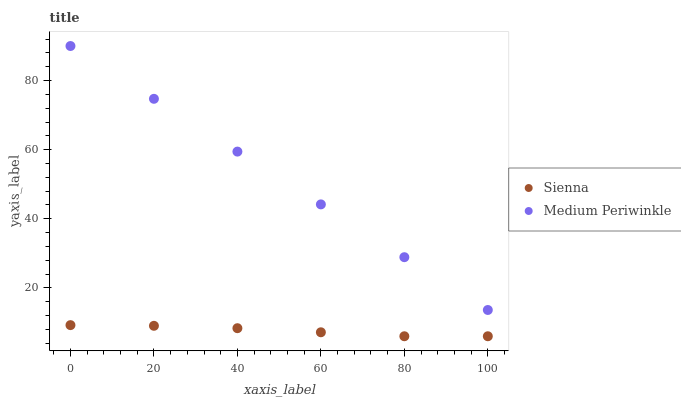Does Sienna have the minimum area under the curve?
Answer yes or no. Yes. Does Medium Periwinkle have the maximum area under the curve?
Answer yes or no. Yes. Does Medium Periwinkle have the minimum area under the curve?
Answer yes or no. No. Is Medium Periwinkle the smoothest?
Answer yes or no. Yes. Is Sienna the roughest?
Answer yes or no. Yes. Is Medium Periwinkle the roughest?
Answer yes or no. No. Does Sienna have the lowest value?
Answer yes or no. Yes. Does Medium Periwinkle have the lowest value?
Answer yes or no. No. Does Medium Periwinkle have the highest value?
Answer yes or no. Yes. Is Sienna less than Medium Periwinkle?
Answer yes or no. Yes. Is Medium Periwinkle greater than Sienna?
Answer yes or no. Yes. Does Sienna intersect Medium Periwinkle?
Answer yes or no. No. 